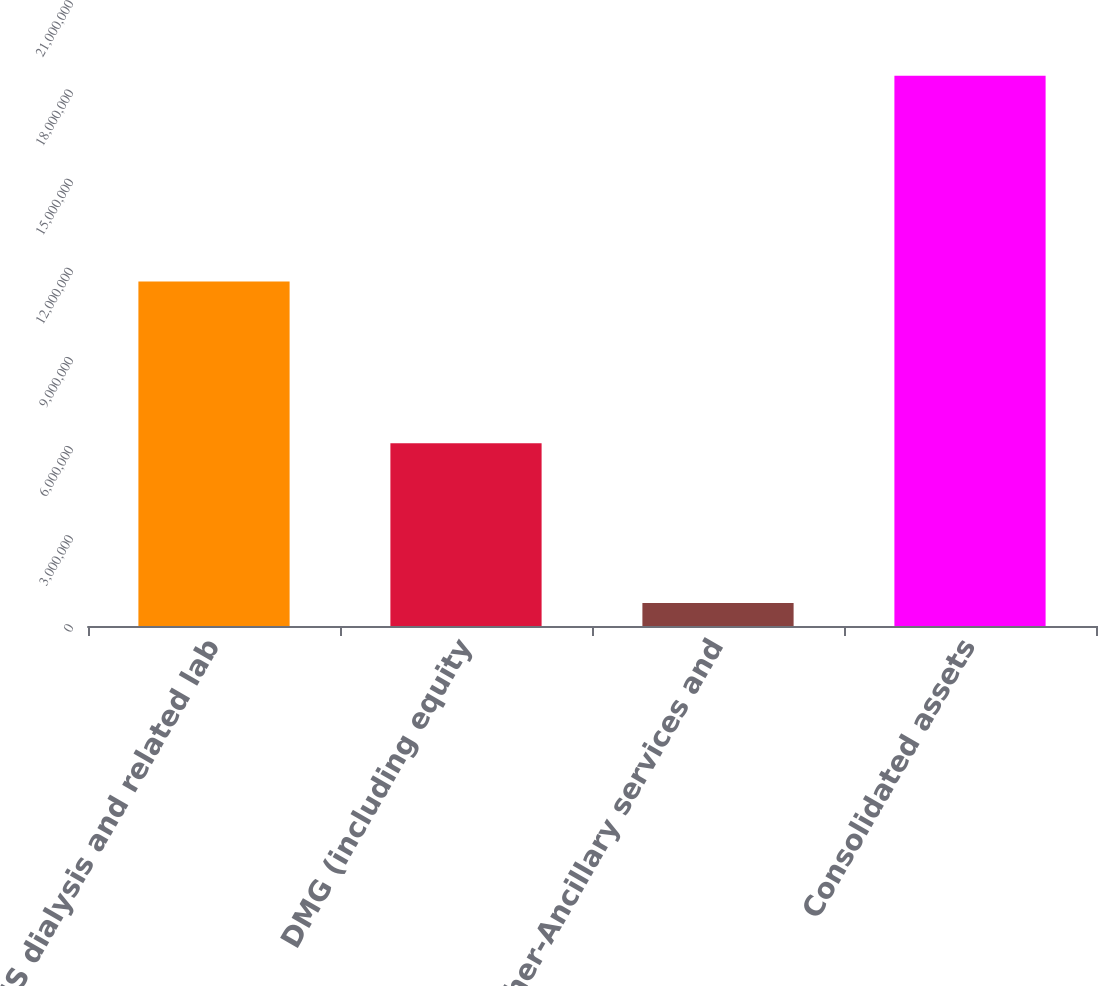Convert chart. <chart><loc_0><loc_0><loc_500><loc_500><bar_chart><fcel>US dialysis and related lab<fcel>DMG (including equity<fcel>Other-Ancillary services and<fcel>Consolidated assets<nl><fcel>1.15915e+07<fcel>6.15067e+06<fcel>772702<fcel>1.85149e+07<nl></chart> 